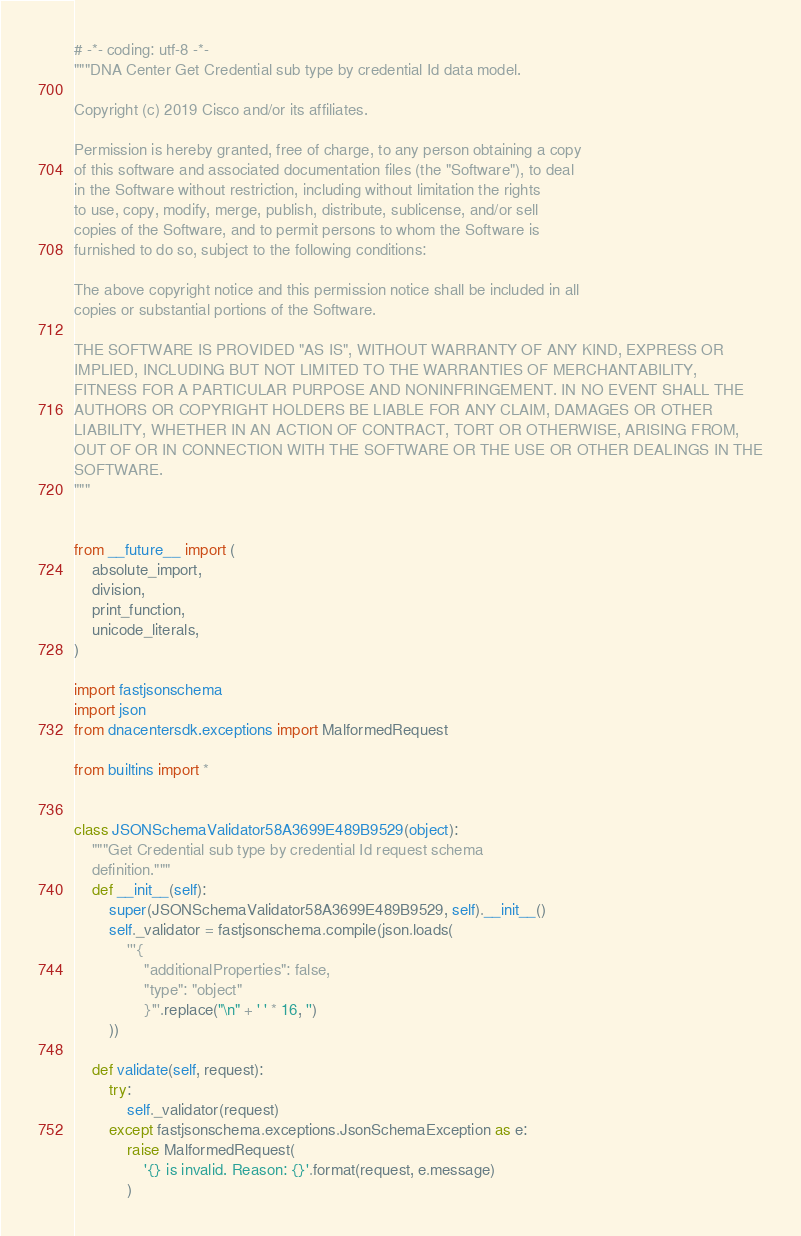<code> <loc_0><loc_0><loc_500><loc_500><_Python_># -*- coding: utf-8 -*-
"""DNA Center Get Credential sub type by credential Id data model.

Copyright (c) 2019 Cisco and/or its affiliates.

Permission is hereby granted, free of charge, to any person obtaining a copy
of this software and associated documentation files (the "Software"), to deal
in the Software without restriction, including without limitation the rights
to use, copy, modify, merge, publish, distribute, sublicense, and/or sell
copies of the Software, and to permit persons to whom the Software is
furnished to do so, subject to the following conditions:

The above copyright notice and this permission notice shall be included in all
copies or substantial portions of the Software.

THE SOFTWARE IS PROVIDED "AS IS", WITHOUT WARRANTY OF ANY KIND, EXPRESS OR
IMPLIED, INCLUDING BUT NOT LIMITED TO THE WARRANTIES OF MERCHANTABILITY,
FITNESS FOR A PARTICULAR PURPOSE AND NONINFRINGEMENT. IN NO EVENT SHALL THE
AUTHORS OR COPYRIGHT HOLDERS BE LIABLE FOR ANY CLAIM, DAMAGES OR OTHER
LIABILITY, WHETHER IN AN ACTION OF CONTRACT, TORT OR OTHERWISE, ARISING FROM,
OUT OF OR IN CONNECTION WITH THE SOFTWARE OR THE USE OR OTHER DEALINGS IN THE
SOFTWARE.
"""


from __future__ import (
    absolute_import,
    division,
    print_function,
    unicode_literals,
)

import fastjsonschema
import json
from dnacentersdk.exceptions import MalformedRequest

from builtins import *


class JSONSchemaValidator58A3699E489B9529(object):
    """Get Credential sub type by credential Id request schema
    definition."""
    def __init__(self):
        super(JSONSchemaValidator58A3699E489B9529, self).__init__()
        self._validator = fastjsonschema.compile(json.loads(
            '''{
                "additionalProperties": false,
                "type": "object"
                }'''.replace("\n" + ' ' * 16, '')
        ))

    def validate(self, request):
        try:
            self._validator(request)
        except fastjsonschema.exceptions.JsonSchemaException as e:
            raise MalformedRequest(
                '{} is invalid. Reason: {}'.format(request, e.message)
            )
</code> 